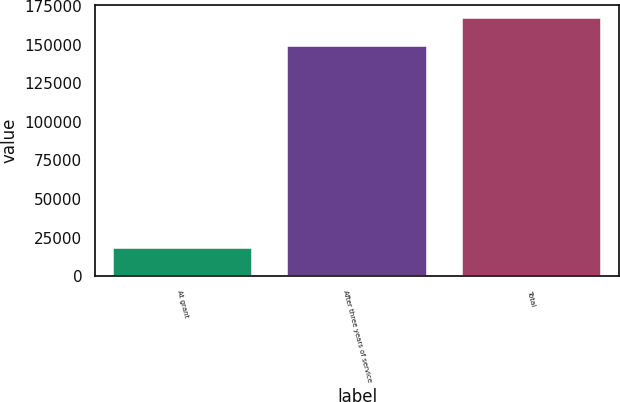<chart> <loc_0><loc_0><loc_500><loc_500><bar_chart><fcel>At grant<fcel>After three years of service<fcel>Total<nl><fcel>18095<fcel>149420<fcel>167515<nl></chart> 